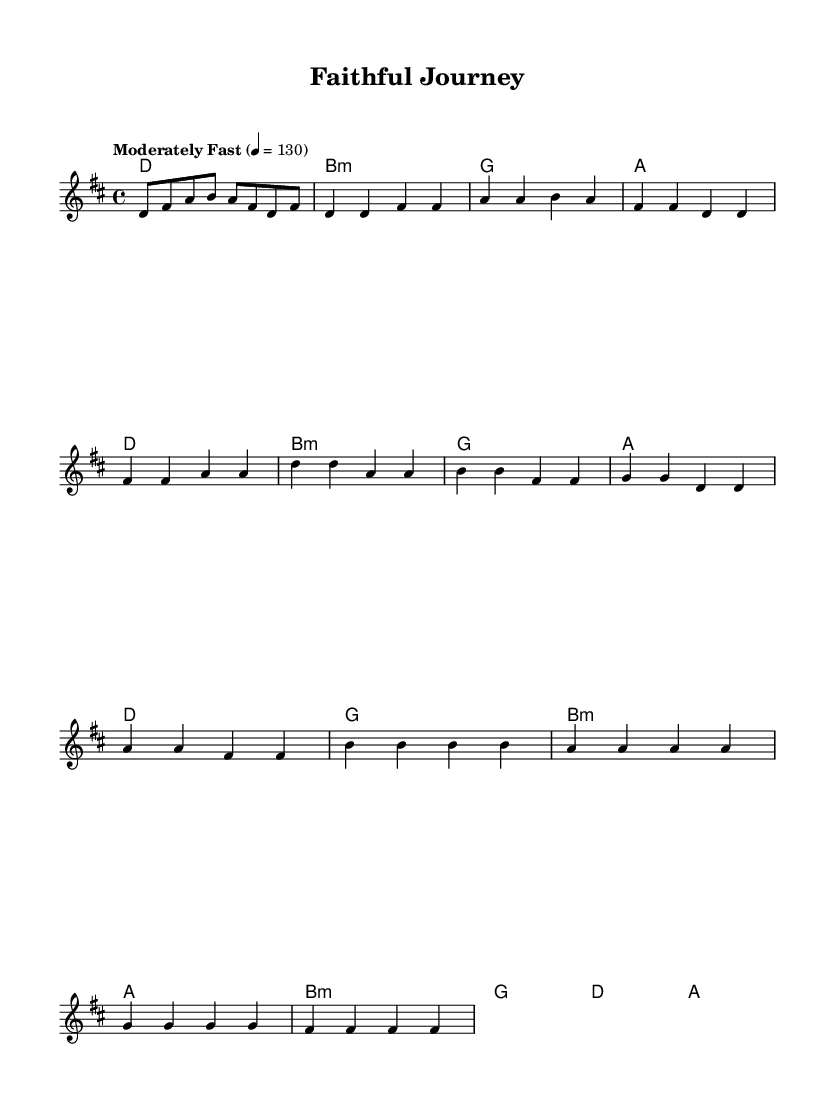What is the key signature of this music? The key signature appears at the beginning of the sheet music and shows two sharps, indicating that the key is D major.
Answer: D major What is the time signature of this music? The time signature is indicated at the beginning of the sheet music as 4/4, which means there are four beats in each measure and the quarter note gets one beat.
Answer: 4/4 What is the tempo marking of this piece? The tempo marking is found at the beginning of the music, where it states "Moderately Fast" with a metronome marking of 130 beats per minute.
Answer: Moderately Fast, 130 How many measures are in the Chorus section? To find the number of measures, we look at the Chorus section in the score, which consists of four measures.
Answer: 4 What chord is used in the Bridge section? The Bridge section starts with the chord B minor followed by G, D, and A in that order. B minor is the first chord in the Bridge.
Answer: B minor Which part of the music is repeated in the Chorus? By examining the structure, the specific melody and harmony from the Verse section are repeated in the Chorus, which emphasizes the themes of faith and perseverance in the lyrics.
Answer: Melody and harmony from the Verse What is the mood established by the chord progressions? The chord progressions in this piece, with a mix of major and minor chords, typically evoke feelings of hope and faith, which aligns with the themes of perseverance often found in religious music.
Answer: Hope and faith 